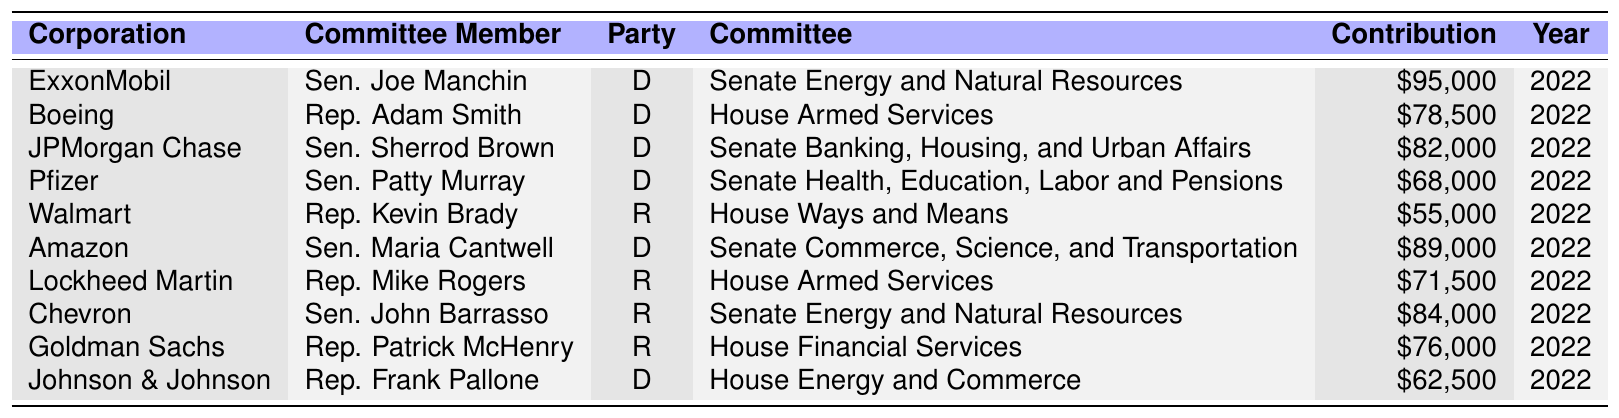What is the highest contribution amount listed in the table? The table shows various contribution amounts. By scanning the "Contribution Amount" column, we can see that the highest amount is $95,000 from ExxonMobil.
Answer: $95,000 Which committee member received a contribution from Pfizer? Referring to the "Corporation" column, Pfizer contributed to Sen. Patty Murray as indicated in the "Committee Member" column.
Answer: Sen. Patty Murray How many contributions were made to Democratic committee members? From the table, we can count the contributions to the Democratic committee members: Sen. Joe Manchin, Rep. Adam Smith, Sen. Sherrod Brown, Sen. Patty Murray, Sen. Maria Cantwell, and Rep. Frank Pallone. This totals to six contributions.
Answer: 6 What is the total contribution amount from Republican corporations listed in the table? First, we identify the contributions from Republican corporations: Walmart ($55,000), Lockheed Martin ($71,500), Chevron ($84,000), and Goldman Sachs ($76,000). Adding these gives $55,000 + $71,500 + $84,000 + $76,000 = $286,500.
Answer: $286,500 Did any committee member receive more than $80,000 in contributions? By checking the "Contribution Amount" values, ExxonMobil ($95,000), JPMorgan Chase ($82,000), and Chevron ($84,000) received amounts exceeding $80,000, confirming that multiple committee members did receive amounts greater than $80,000.
Answer: Yes What is the average contribution amount across all committee members? We first sum the contributions: ($95,000 + $78,500 + $82,000 + $68,000 + $55,000 + $89,000 + $71,500 + $84,000 + $76,000 + $62,500) = $786,000. Next, we note there are 10 contributions, thus averaging it gives $786,000 / 10 = $78,600.
Answer: $78,600 Which corporation contributed the least and who was the corresponding committee member? From the table, Walmart contributed the least at $55,000 to Rep. Kevin Brady, which can be verified by checking the lowest amount in the "Contribution Amount" column.
Answer: Walmart, Rep. Kevin Brady Is there any committee member who received contributions from more than one corporation? Reviewing the table, each committee member is linked to a single corporation based on the data provided. Thus, there are no committee members with contributions from multiple corporations.
Answer: No 